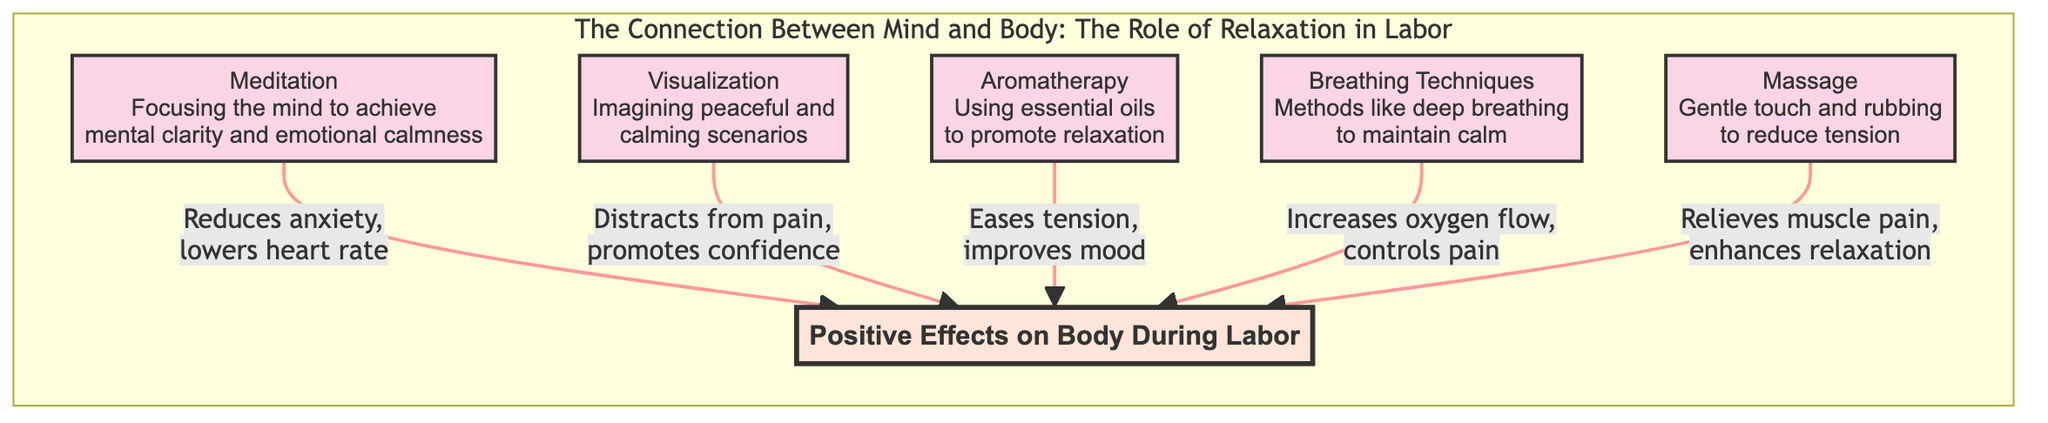What is the main focus of the diagram? The diagram centers on the connection between the mind and body, specifically highlighting the role of relaxation during labor. This is established by the title "The Connection Between Mind and Body: The Role of Relaxation in Labor."
Answer: The role of relaxation in labor How many relaxation techniques are mentioned in the diagram? The diagram lists five relaxation techniques: meditation, visualization, aromatherapy, breathing techniques, and massage. Counting each of these nodes gives us the total.
Answer: Five What positive effect is associated with meditation? The diagram notes that meditation reduces anxiety and lowers heart rate, which can positively affect the body during labor as indicated in the link from the meditation node to the body-mind connection node.
Answer: Reduces anxiety, lowers heart rate Which technique is related to using essential oils? The aromatherapy node specifies that it involves using essential oils, with the connected effect being easing tension and improving mood.
Answer: Aromatherapy What is one effect of breathing techniques noted in the diagram? The diagram indicates that breathing techniques increase oxygen flow and control pain. To find this, we look at the arrow leading from the breathing techniques node to the body-mind connection.
Answer: Increases oxygen flow, controls pain Which technique helps promote confidence during labor? The visualization node specifies it helps by distracting from pain and promoting confidence. This is indicated by the direct link from the visualization node to the body-mind connection.
Answer: Visualization Which relaxation technique is mentioned as reducing muscle pain? The massage node in the diagram states that it relieves muscle pain while enhancing relaxation, as shown by the connection to the body-mind connection node.
Answer: Massage How does aromatherapy positively affect mood? The aromatherapy section shows that it eases tension and improves mood, indicating this connection between the use of essential oils and its mental effects during labor.
Answer: Eases tension, improves mood What is the shared benefit of both meditation and breathing techniques? Both meditation and breathing techniques are associated with calming the mind and body—meditation by reducing anxiety and breathing techniques by maintaining calm through deep breathing.
Answer: Promotes calmness 